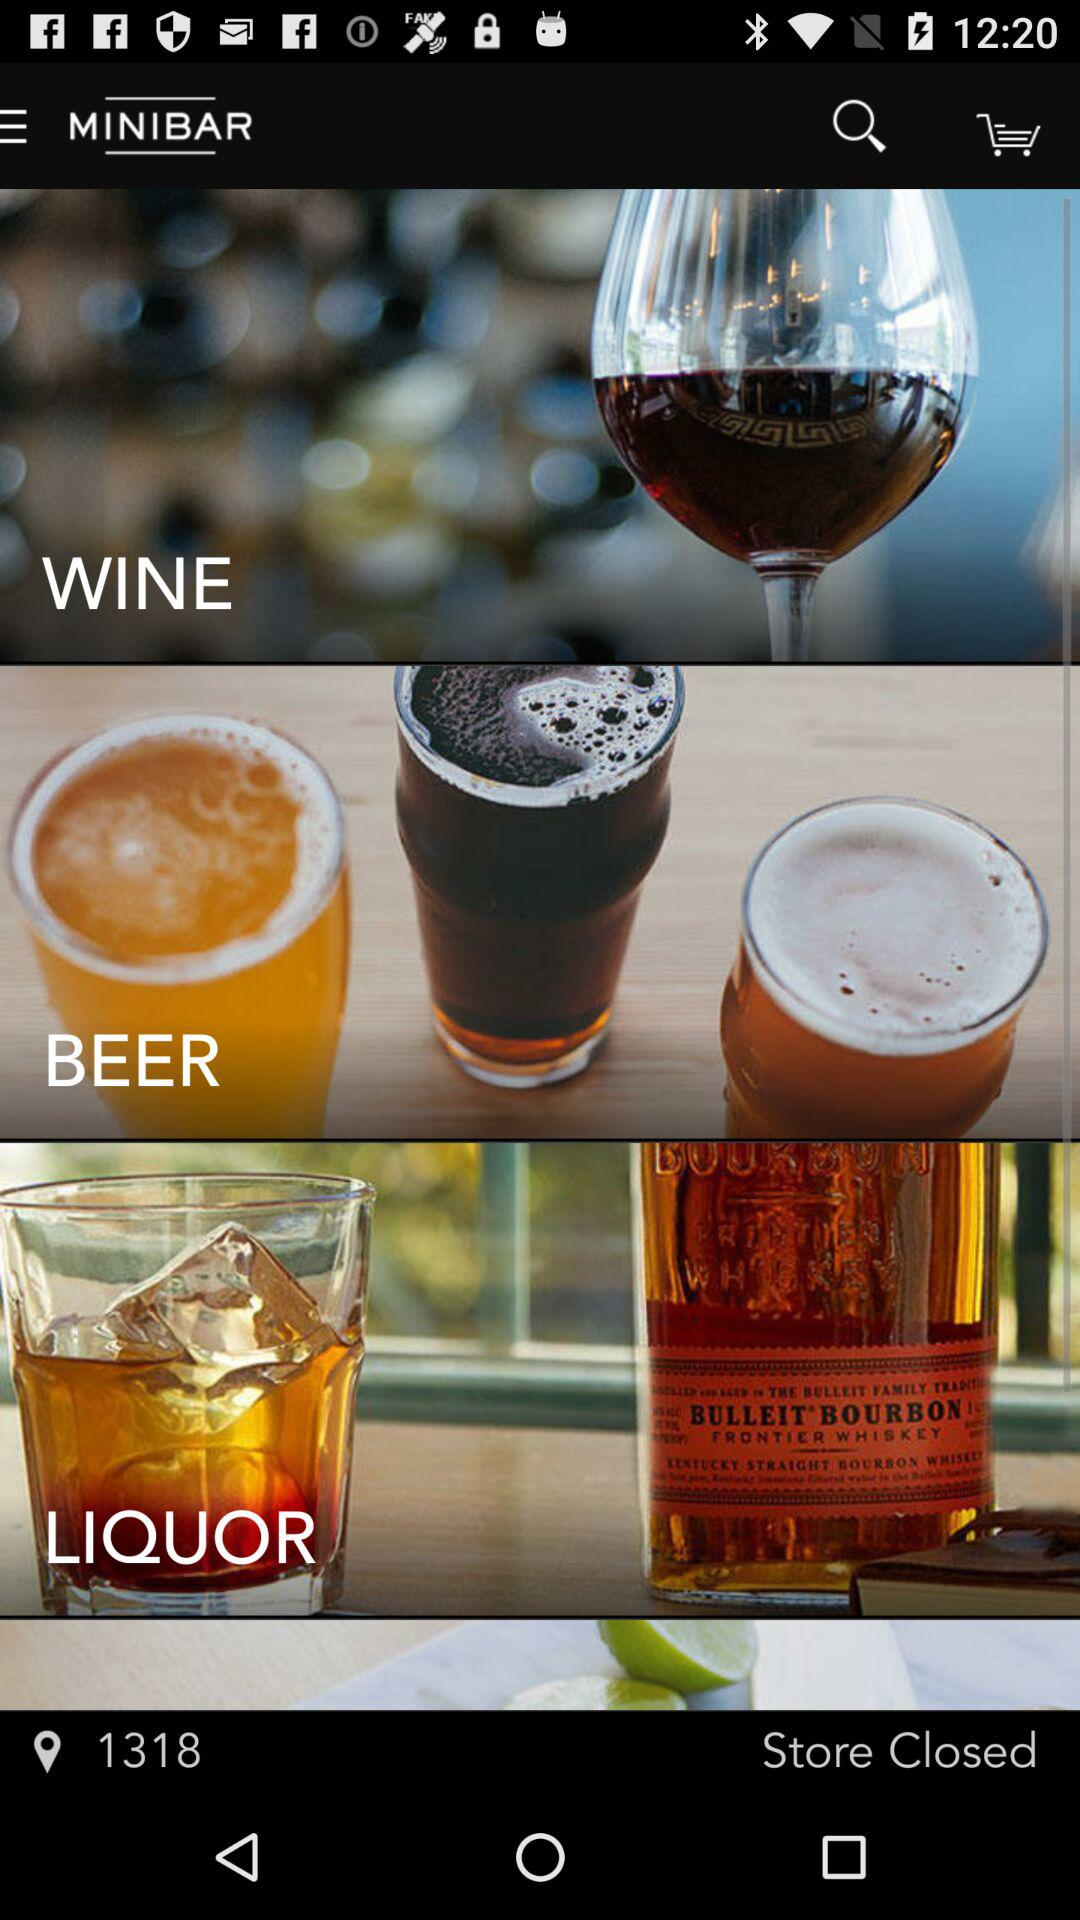What are the options in "MINIBAR"? The options are "WINE", "BEER" and "LIQUOR". 